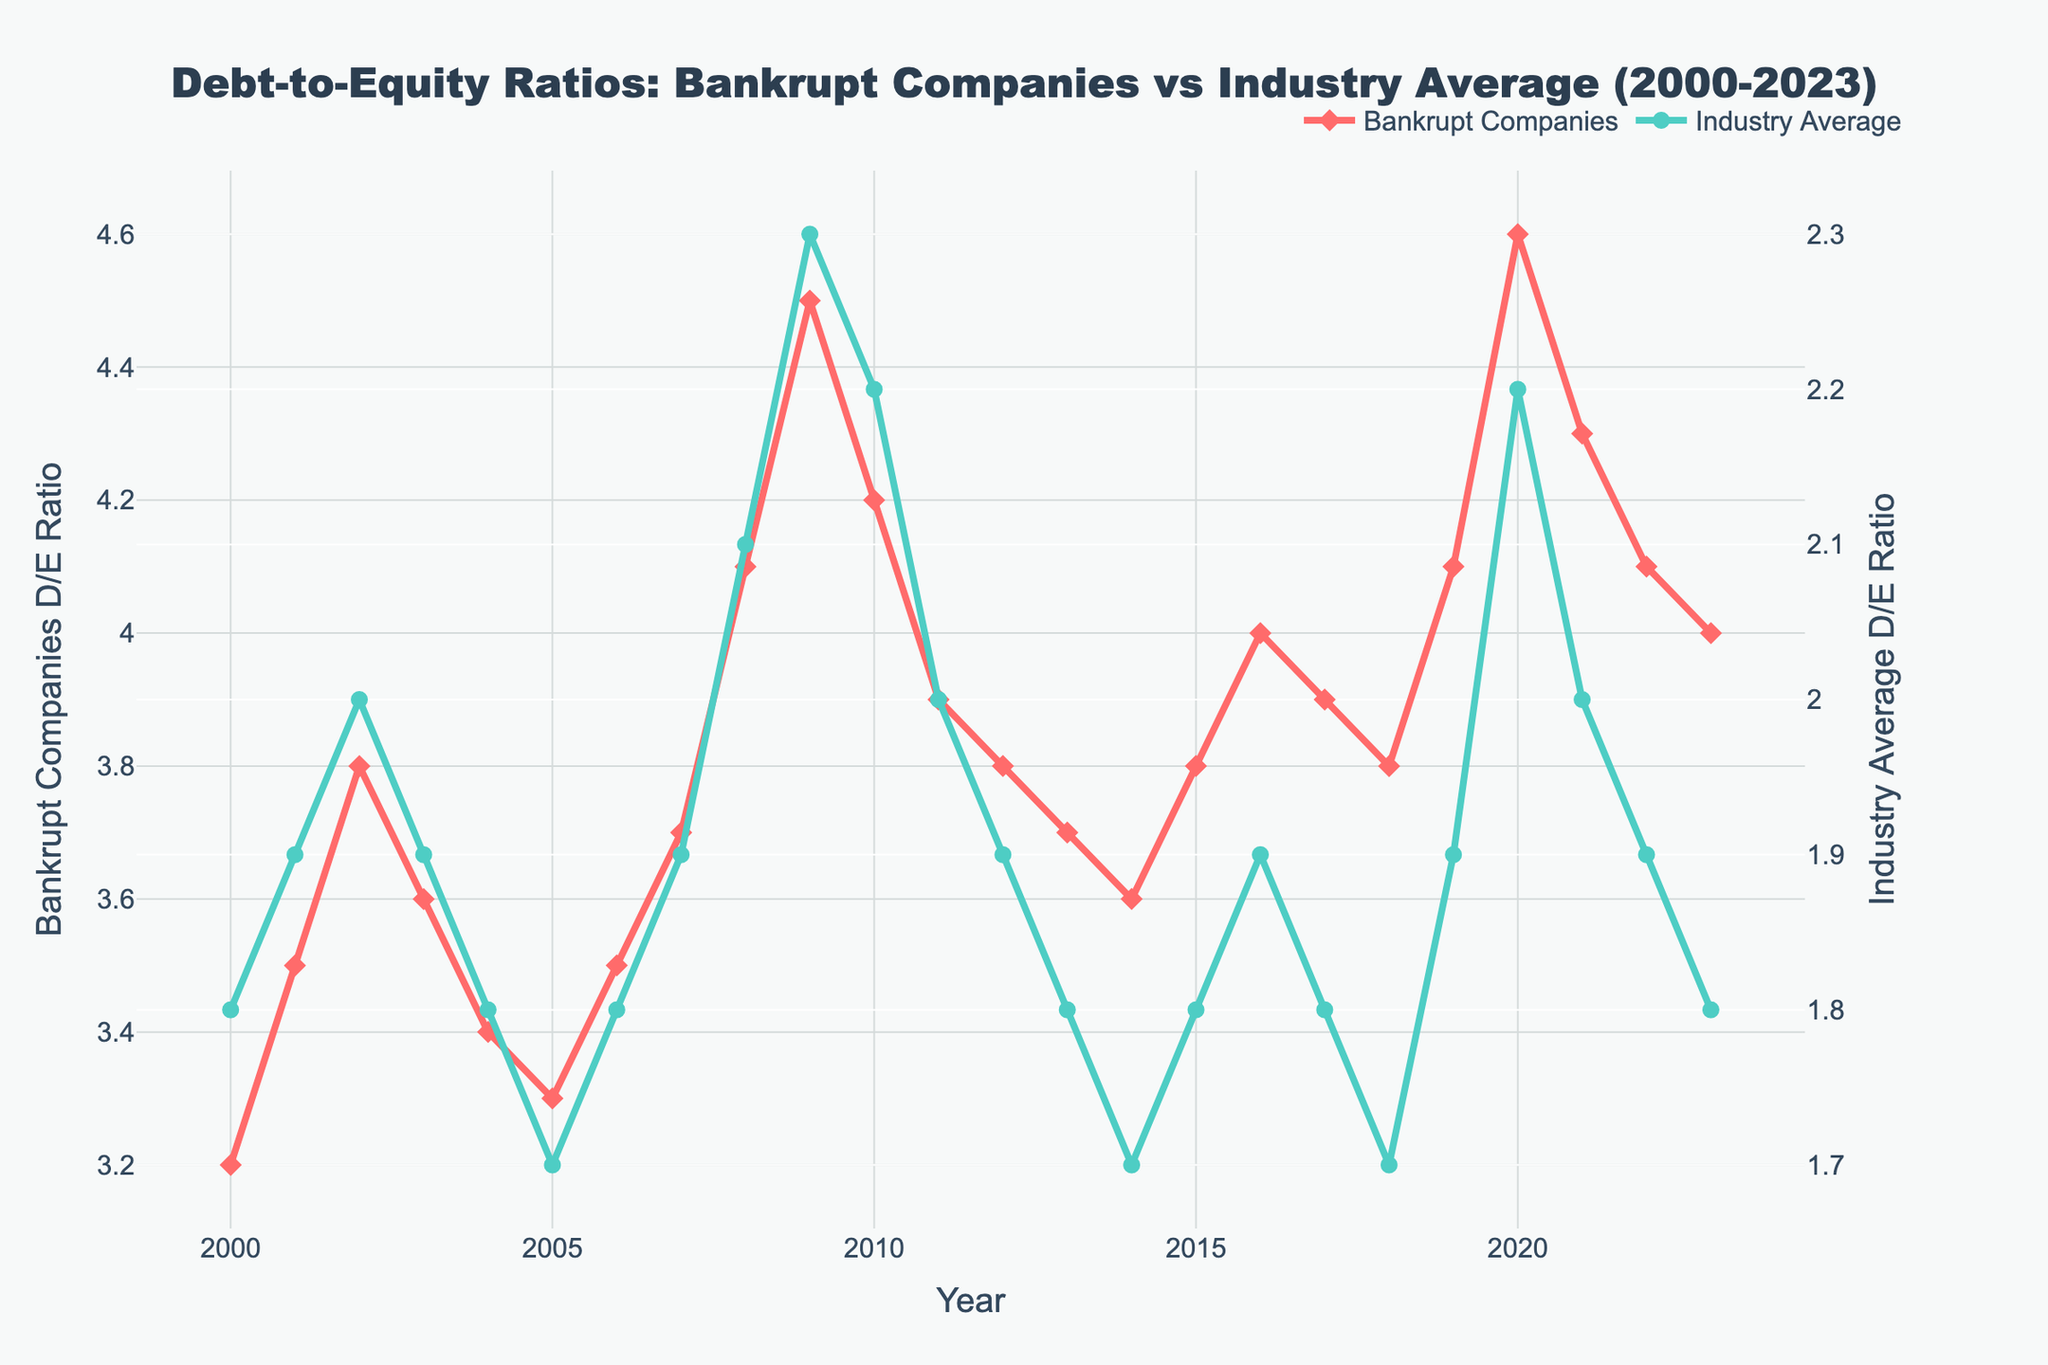What has the highest Debt-to-Equity ratio for Bankrupt Companies? The figure shows the Debt-to-Equity ratios for Bankrupt Companies over the years, and the highest value can be identified by looking for the peak point in the line representing Bankrupt Companies. The highest value is shown in 2020.
Answer: 4.6 What year shows the largest difference between Bankrupt Companies' and Industry Average D/E Ratios? To find the year with the largest difference, look for the largest vertical gap between the two lines representing Bankrupt Companies and Industry Average in the figure. The year 2020 shows the largest difference.
Answer: 2020 By how much did the D/E ratio for Bankrupt Companies decrease from 2009 to 2010? The D/E ratio for Bankrupt Companies in 2009 was 4.5, and in 2010 it was 4.2. The decrease is calculated by subtracting the ratio in 2010 from that in 2009. Thus, 4.5 - 4.2 = 0.3.
Answer: 0.3 Which year shows Bankrupt Companies' D/E ratio equal to the industry average D/E ratio? By looking for overlapping points between the two lines in the figure, it's clear that there is no point where the D/E ratio for Bankrupt Companies equals the industry average from 2000 to 2023.
Answer: None In which year did both Bankrupt Companies and Industry Average D/E Ratios peak? The year when both ratios had their respective peaks can be identified by looking for the highest points in each line. For Bankrupt Companies, it's 2020, and for the Industry Average, it's 2009.
Answer: 2020; 2009 By how much did the Industry Average D/E ratio increase from 2000 to 2023? The Industry Average D/E ratio in 2000 was 1.8, and in 2023 it was also 1.8. The increase is calculated by subtracting the value in 2000 from the value in 2023. So, 1.8 - 1.8 = 0.
Answer: 0 